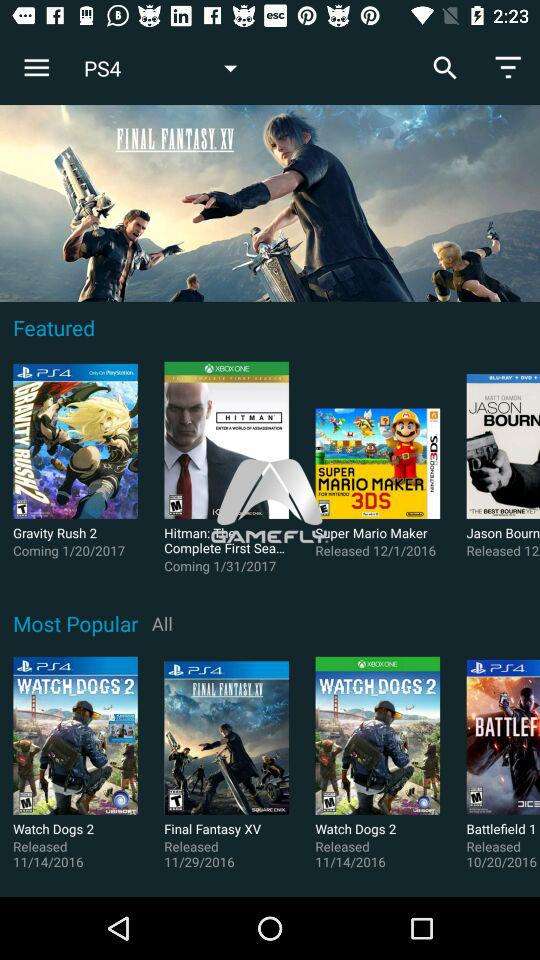What are the featured games for the PS4? The featured games for the PS4 are "Gravity Rush 2", "Hitman: The Complete First Sea..." and "Super Mario Maker". 